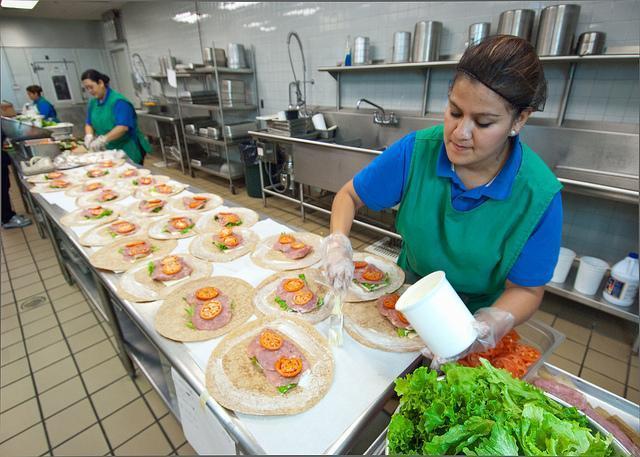How many people are there?
Give a very brief answer. 2. How many of the people on the bench are holding umbrellas ?
Give a very brief answer. 0. 